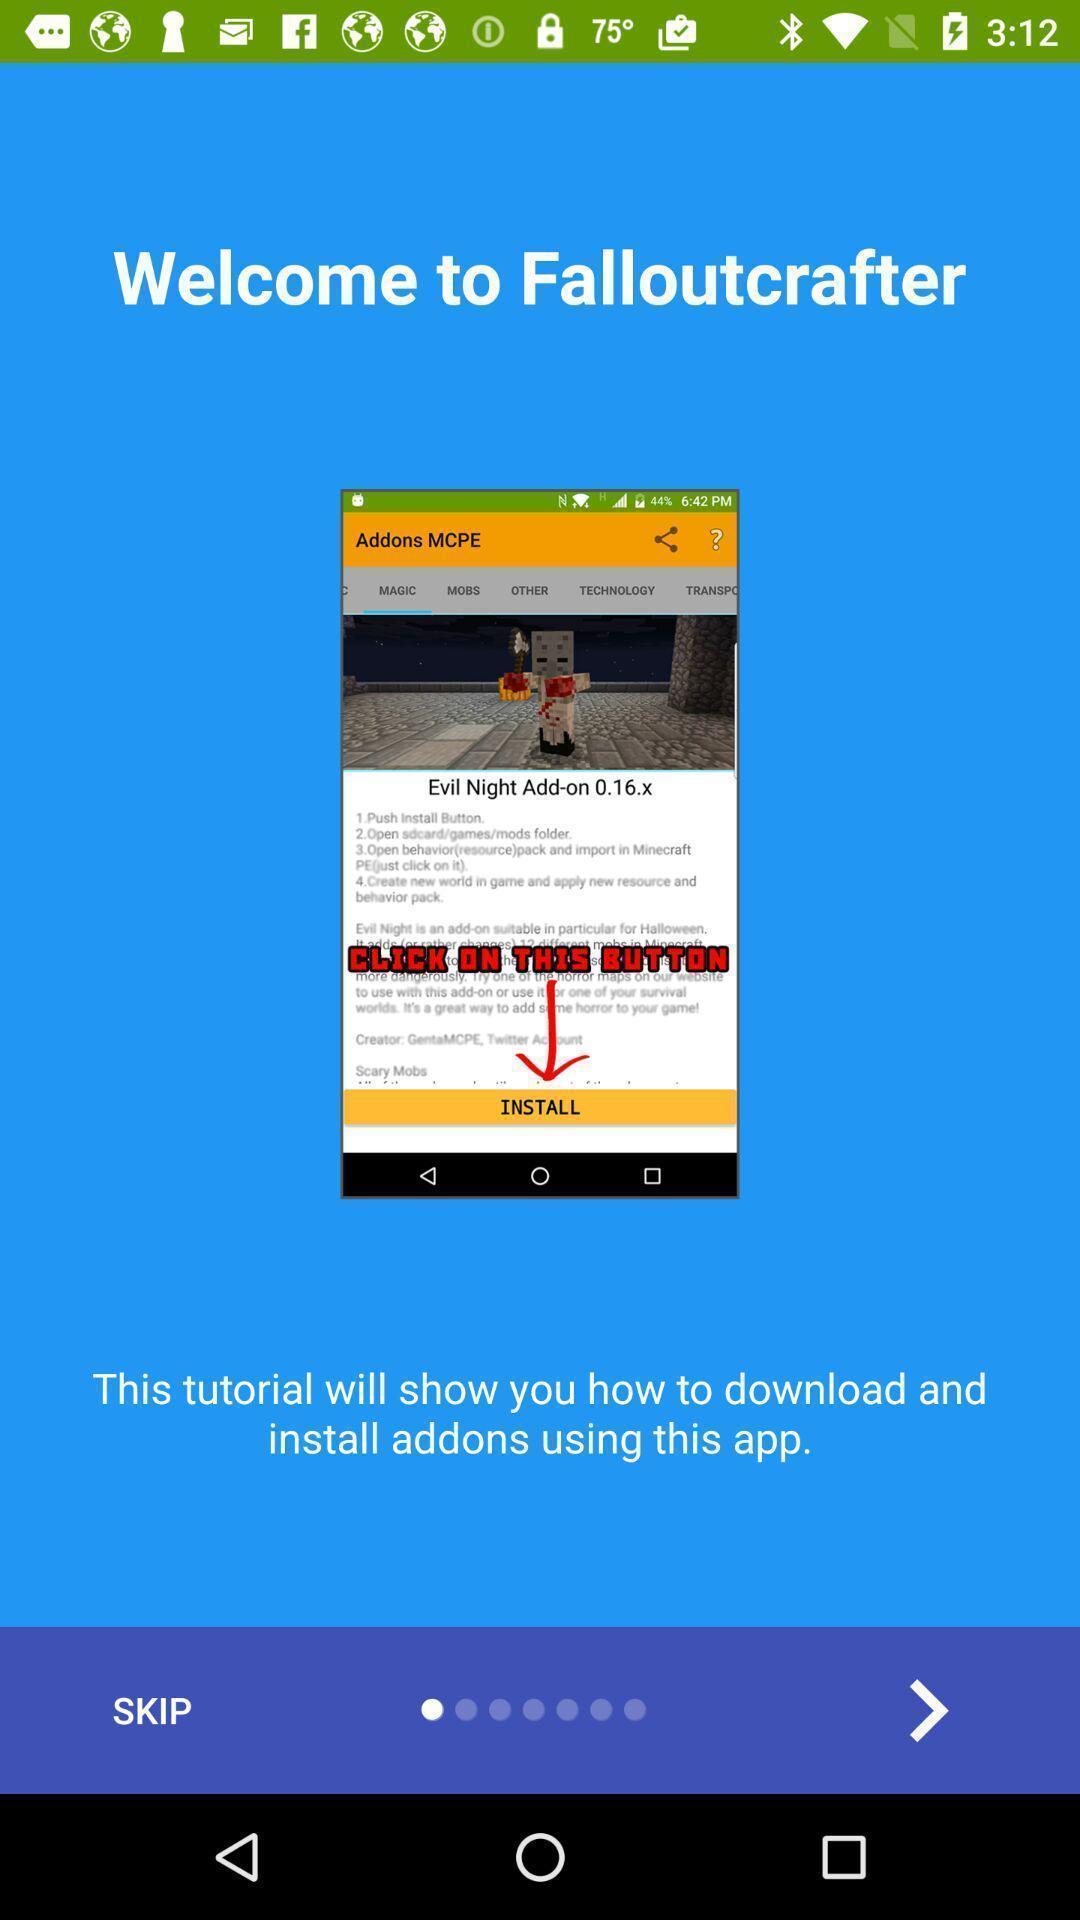Give me a summary of this screen capture. Welcome page of an game application. 